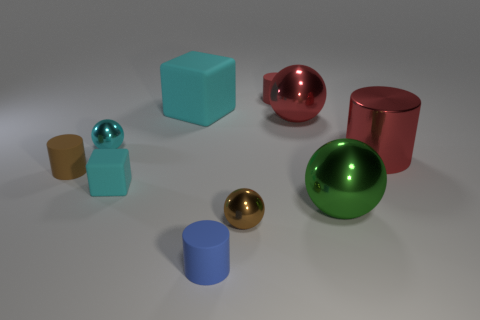Subtract all small cylinders. How many cylinders are left? 1 Subtract all green cubes. How many green cylinders are left? 0 Subtract all green spheres. How many spheres are left? 3 Subtract 1 green balls. How many objects are left? 9 Subtract all cylinders. How many objects are left? 6 Subtract 2 cylinders. How many cylinders are left? 2 Subtract all gray balls. Subtract all brown cubes. How many balls are left? 4 Subtract all large red metallic objects. Subtract all large cyan things. How many objects are left? 7 Add 7 small brown rubber cylinders. How many small brown rubber cylinders are left? 8 Add 7 red shiny spheres. How many red shiny spheres exist? 8 